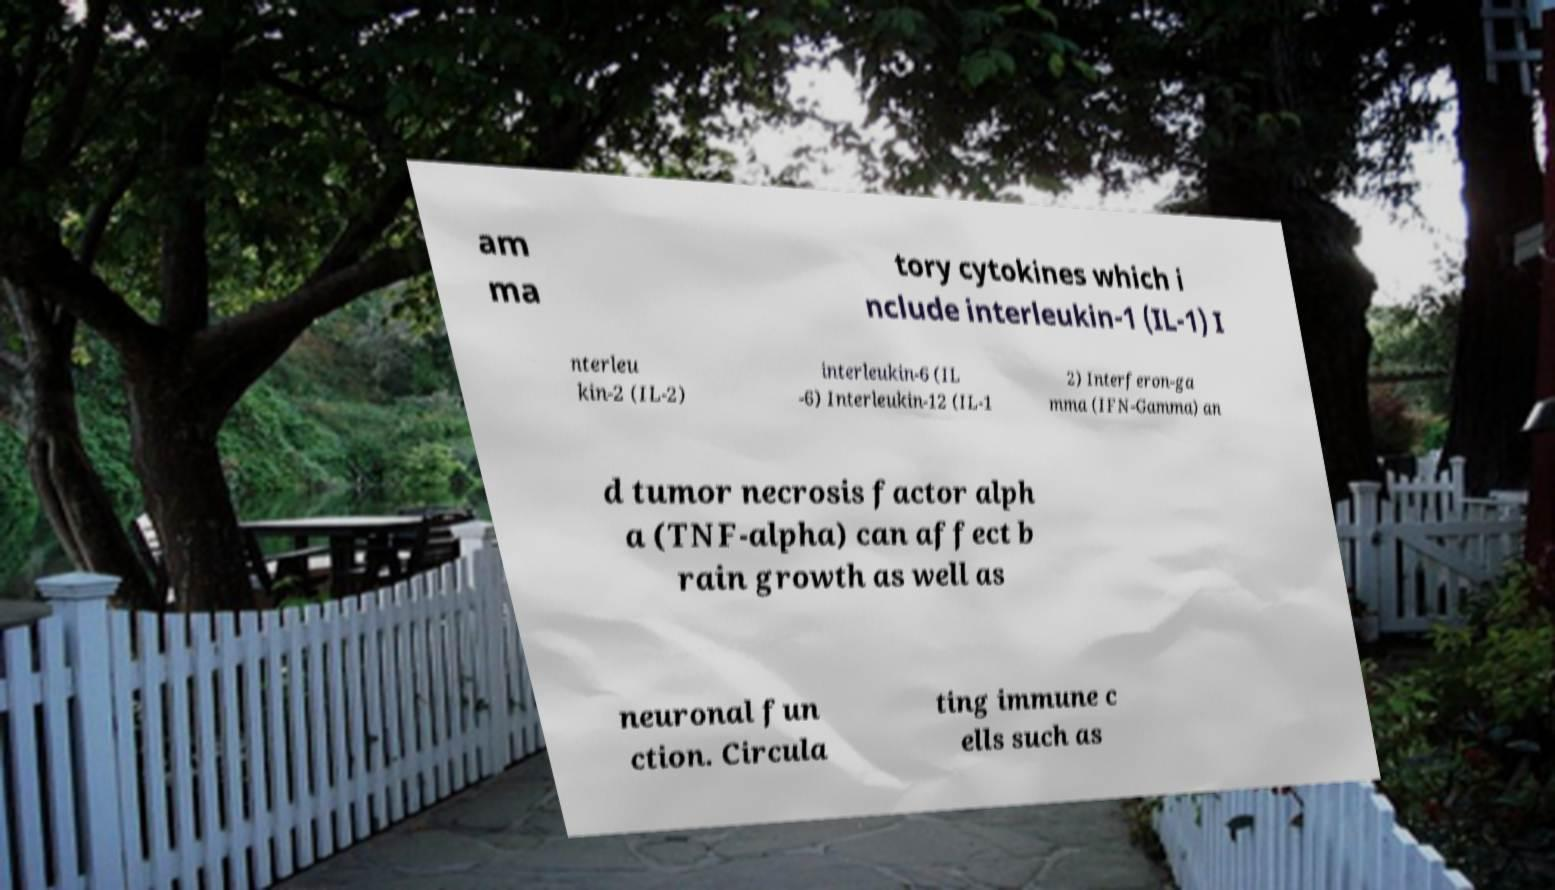Please read and relay the text visible in this image. What does it say? am ma tory cytokines which i nclude interleukin-1 (IL-1) I nterleu kin-2 (IL-2) interleukin-6 (IL -6) Interleukin-12 (IL-1 2) Interferon-ga mma (IFN-Gamma) an d tumor necrosis factor alph a (TNF-alpha) can affect b rain growth as well as neuronal fun ction. Circula ting immune c ells such as 